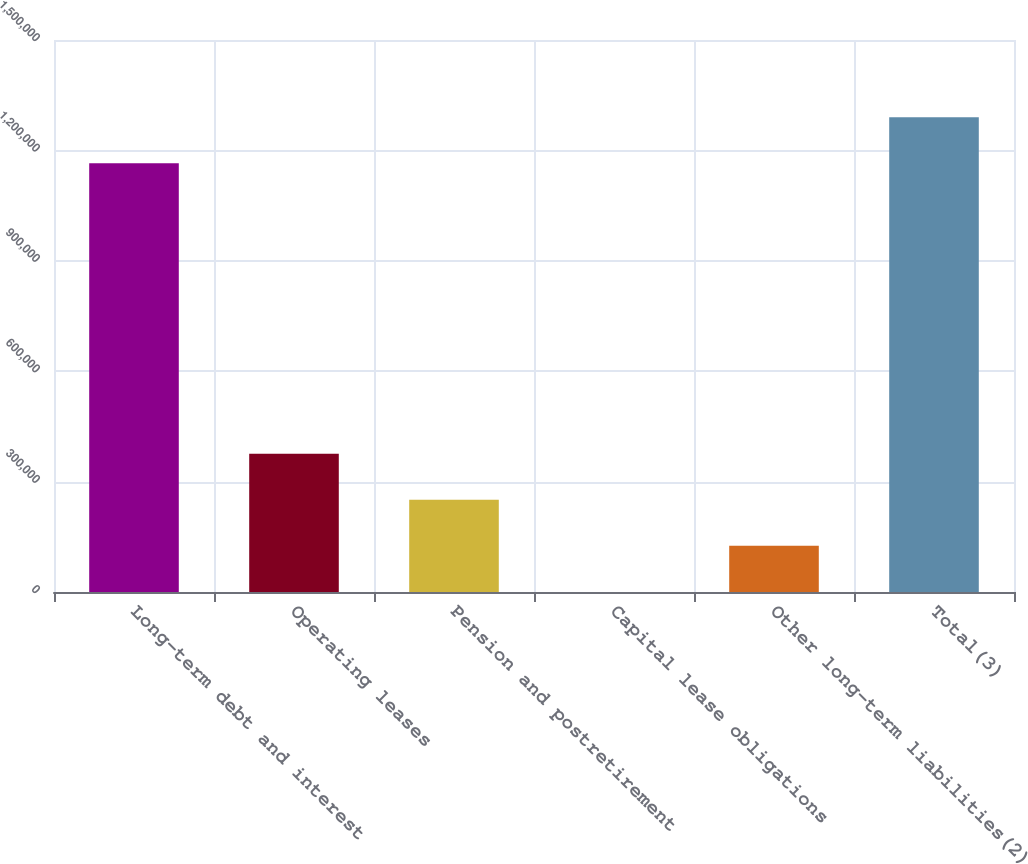Convert chart to OTSL. <chart><loc_0><loc_0><loc_500><loc_500><bar_chart><fcel>Long-term debt and interest<fcel>Operating leases<fcel>Pension and postretirement<fcel>Capital lease obligations<fcel>Other long-term liabilities(2)<fcel>Total(3)<nl><fcel>1.16483e+06<fcel>375977<fcel>250716<fcel>194<fcel>125455<fcel>1.29009e+06<nl></chart> 